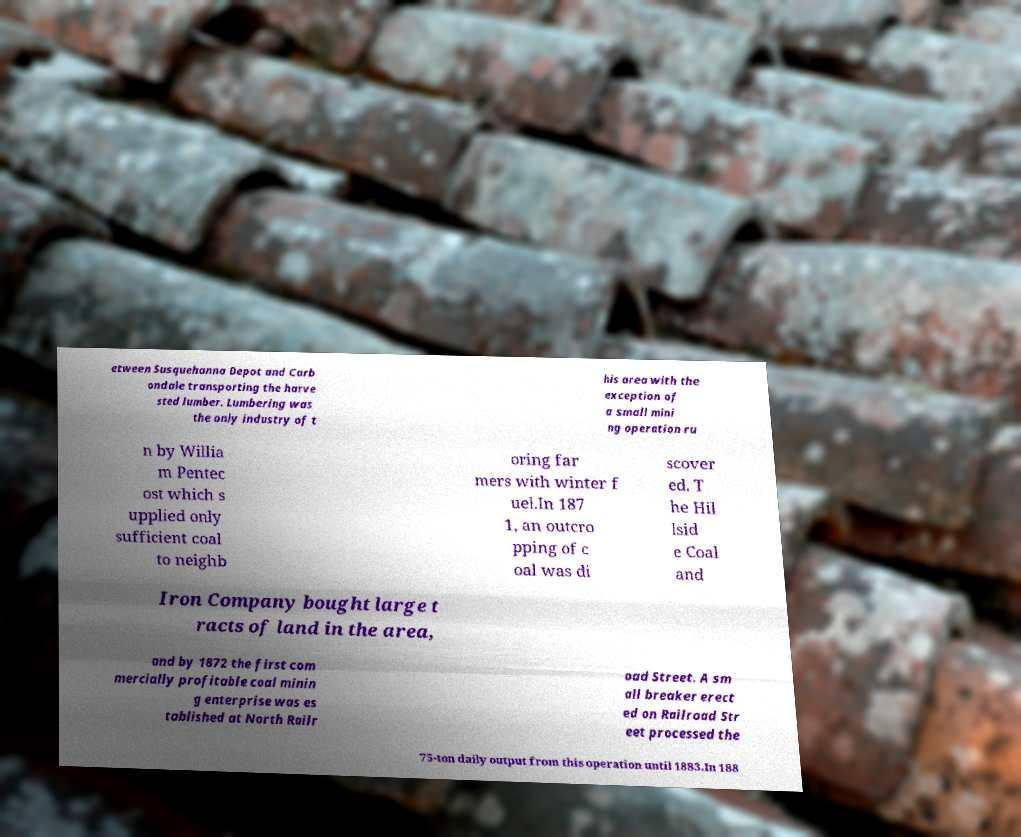I need the written content from this picture converted into text. Can you do that? etween Susquehanna Depot and Carb ondale transporting the harve sted lumber. Lumbering was the only industry of t his area with the exception of a small mini ng operation ru n by Willia m Pentec ost which s upplied only sufficient coal to neighb oring far mers with winter f uel.In 187 1, an outcro pping of c oal was di scover ed. T he Hil lsid e Coal and Iron Company bought large t racts of land in the area, and by 1872 the first com mercially profitable coal minin g enterprise was es tablished at North Railr oad Street. A sm all breaker erect ed on Railroad Str eet processed the 75-ton daily output from this operation until 1883.In 188 